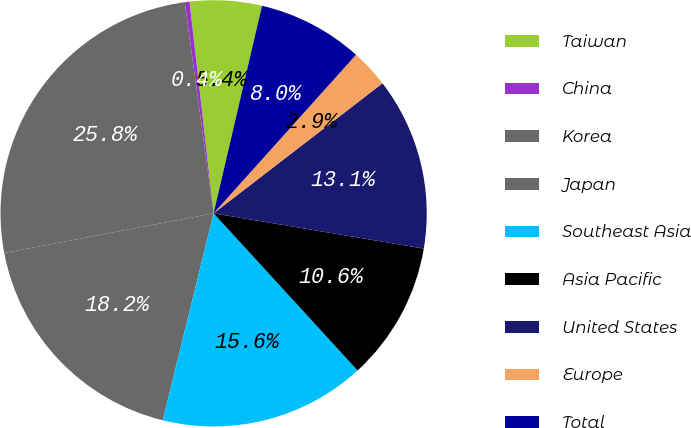<chart> <loc_0><loc_0><loc_500><loc_500><pie_chart><fcel>Taiwan<fcel>China<fcel>Korea<fcel>Japan<fcel>Southeast Asia<fcel>Asia Pacific<fcel>United States<fcel>Europe<fcel>Total<nl><fcel>5.45%<fcel>0.36%<fcel>25.82%<fcel>18.18%<fcel>15.64%<fcel>10.55%<fcel>13.09%<fcel>2.91%<fcel>8.0%<nl></chart> 